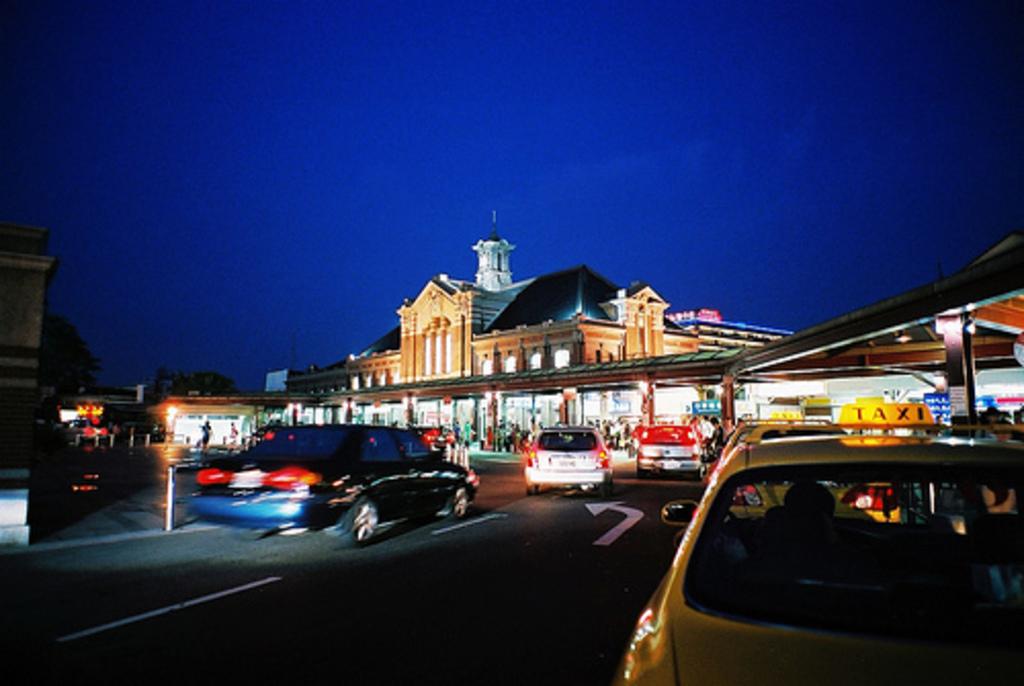What is written in lights on top of the yellow car?
Your answer should be compact. Taxi. 